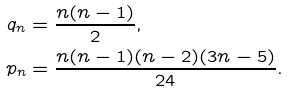<formula> <loc_0><loc_0><loc_500><loc_500>q _ { n } & = \frac { n ( n - 1 ) } { 2 } , \\ p _ { n } & = \frac { n ( n - 1 ) ( n - 2 ) ( 3 n - 5 ) } { 2 4 } .</formula> 